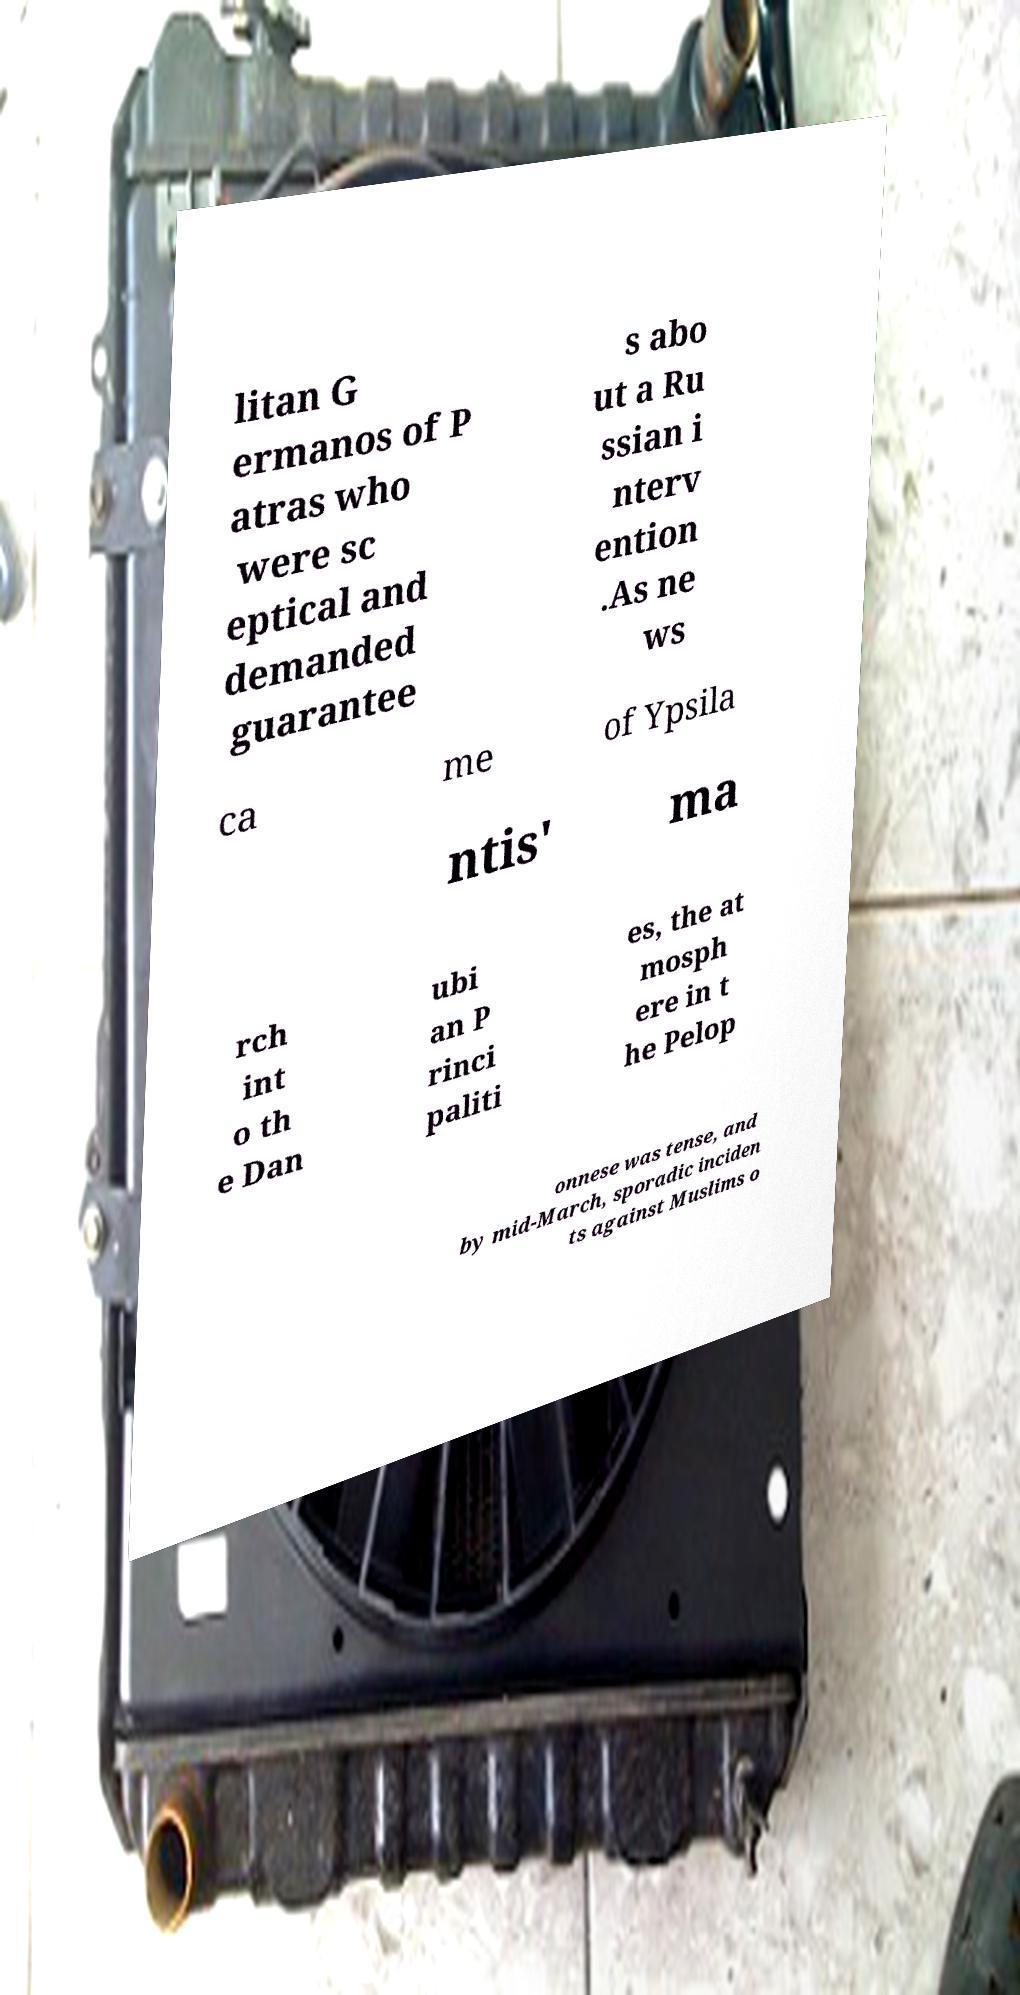Can you accurately transcribe the text from the provided image for me? litan G ermanos of P atras who were sc eptical and demanded guarantee s abo ut a Ru ssian i nterv ention .As ne ws ca me of Ypsila ntis' ma rch int o th e Dan ubi an P rinci paliti es, the at mosph ere in t he Pelop onnese was tense, and by mid-March, sporadic inciden ts against Muslims o 